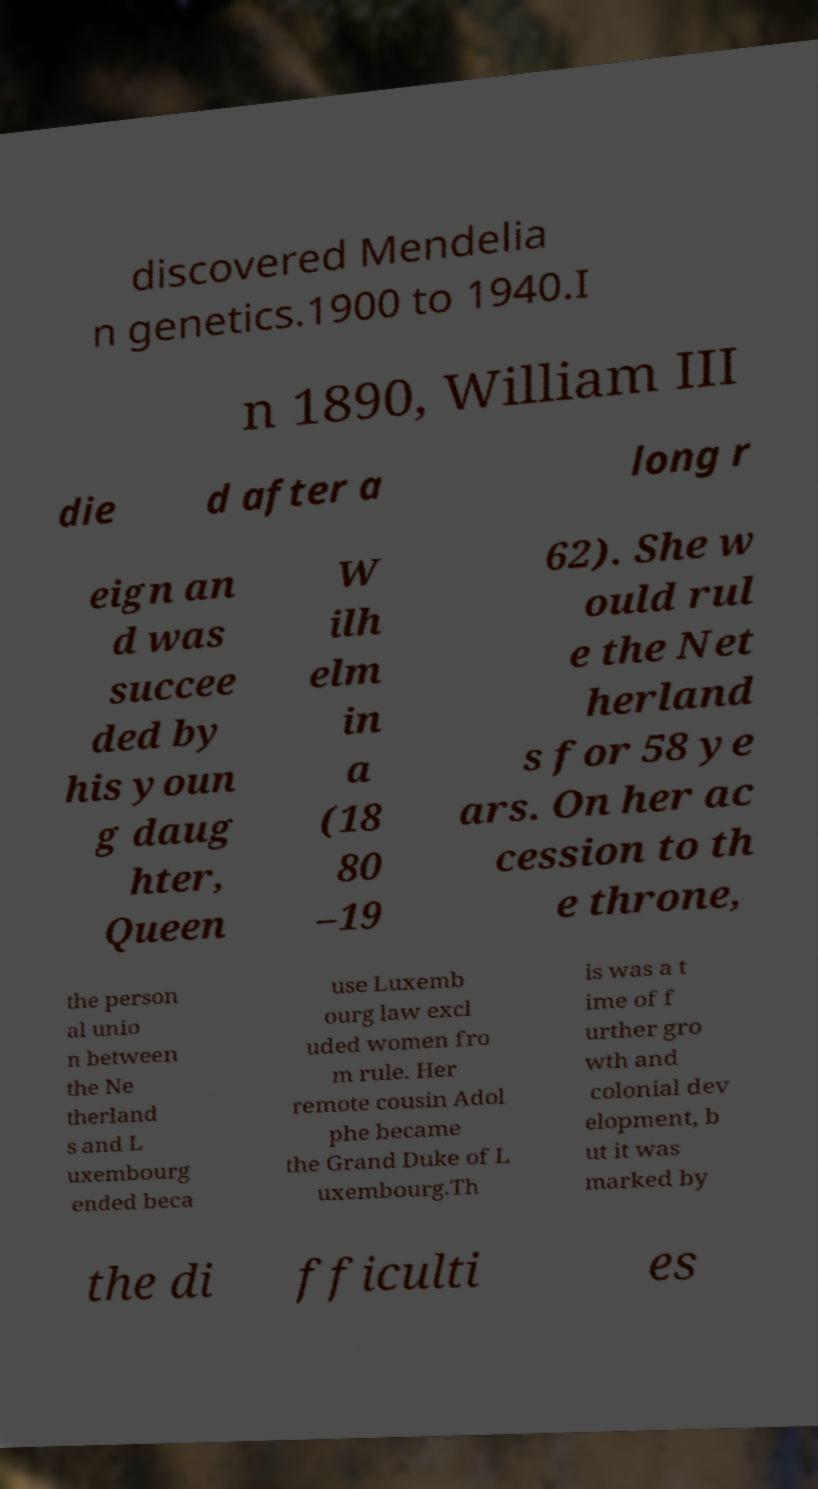For documentation purposes, I need the text within this image transcribed. Could you provide that? discovered Mendelia n genetics.1900 to 1940.I n 1890, William III die d after a long r eign an d was succee ded by his youn g daug hter, Queen W ilh elm in a (18 80 –19 62). She w ould rul e the Net herland s for 58 ye ars. On her ac cession to th e throne, the person al unio n between the Ne therland s and L uxembourg ended beca use Luxemb ourg law excl uded women fro m rule. Her remote cousin Adol phe became the Grand Duke of L uxembourg.Th is was a t ime of f urther gro wth and colonial dev elopment, b ut it was marked by the di fficulti es 